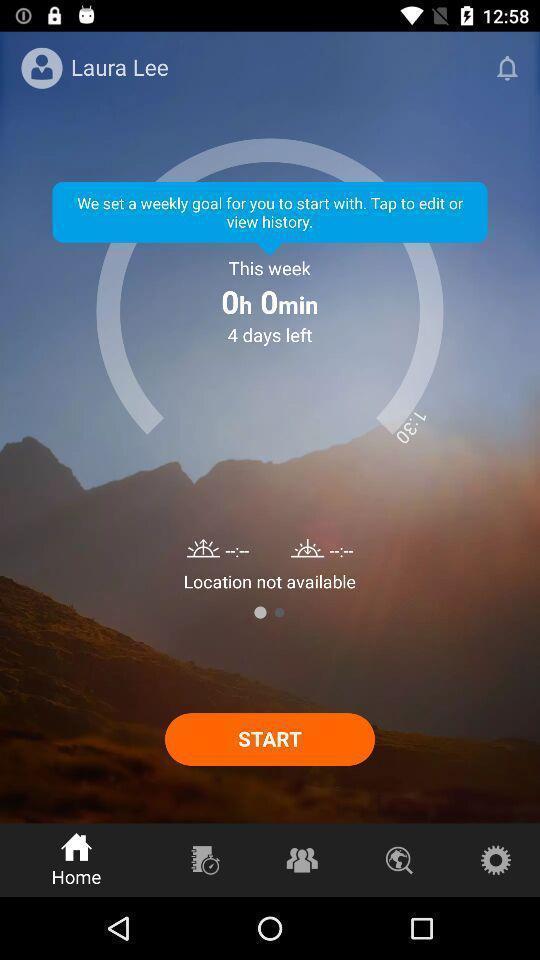Provide a textual representation of this image. Welcome page of fitness app. 